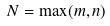<formula> <loc_0><loc_0><loc_500><loc_500>N = \max ( m , n )</formula> 